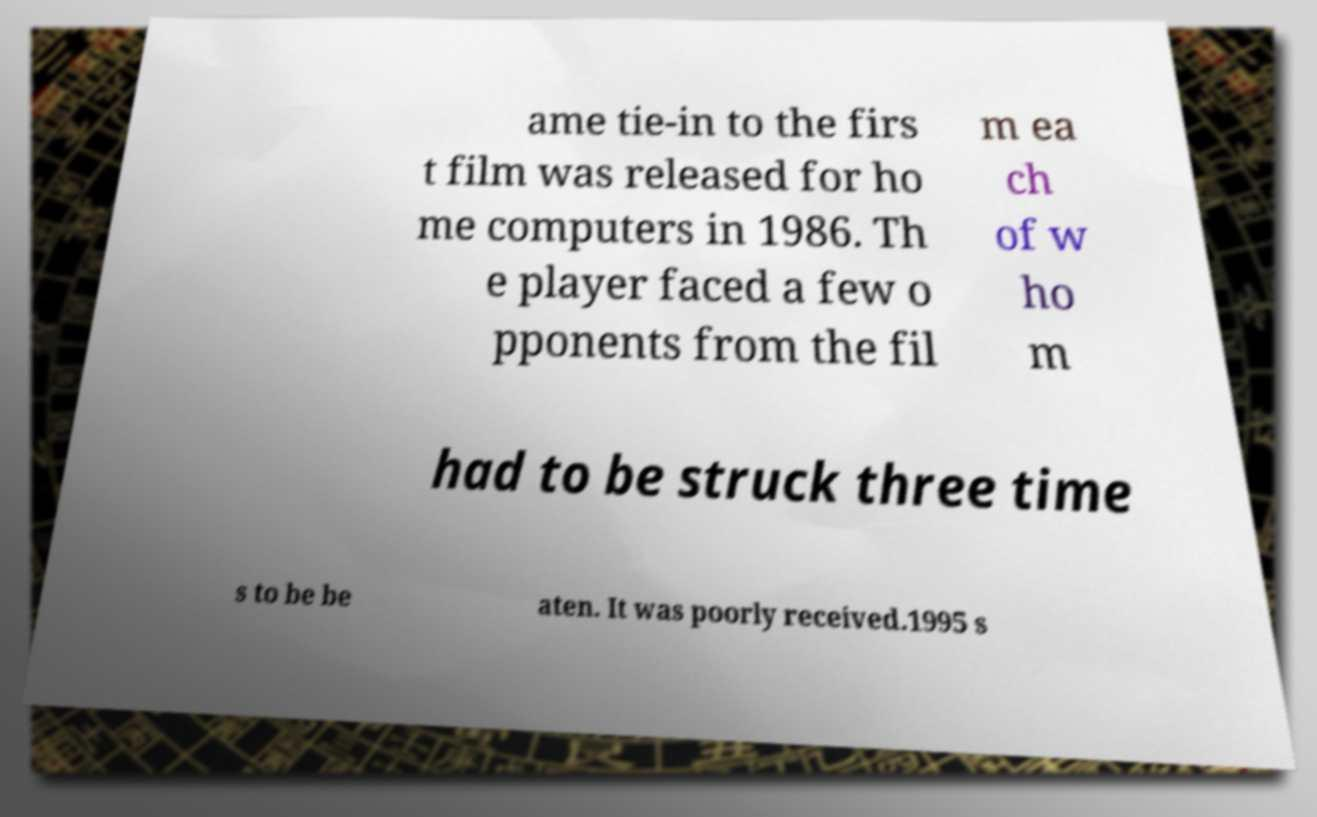There's text embedded in this image that I need extracted. Can you transcribe it verbatim? ame tie-in to the firs t film was released for ho me computers in 1986. Th e player faced a few o pponents from the fil m ea ch of w ho m had to be struck three time s to be be aten. It was poorly received.1995 s 